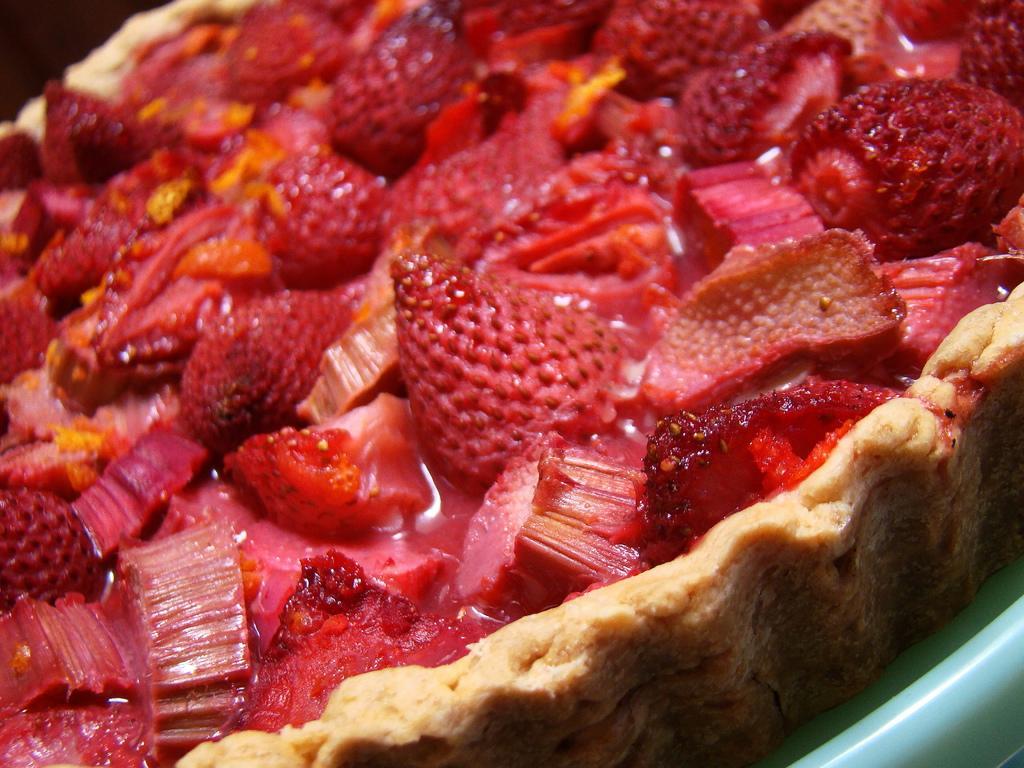Describe this image in one or two sentences. In this image, I can see a food item with strawberries and few other ingredients. 